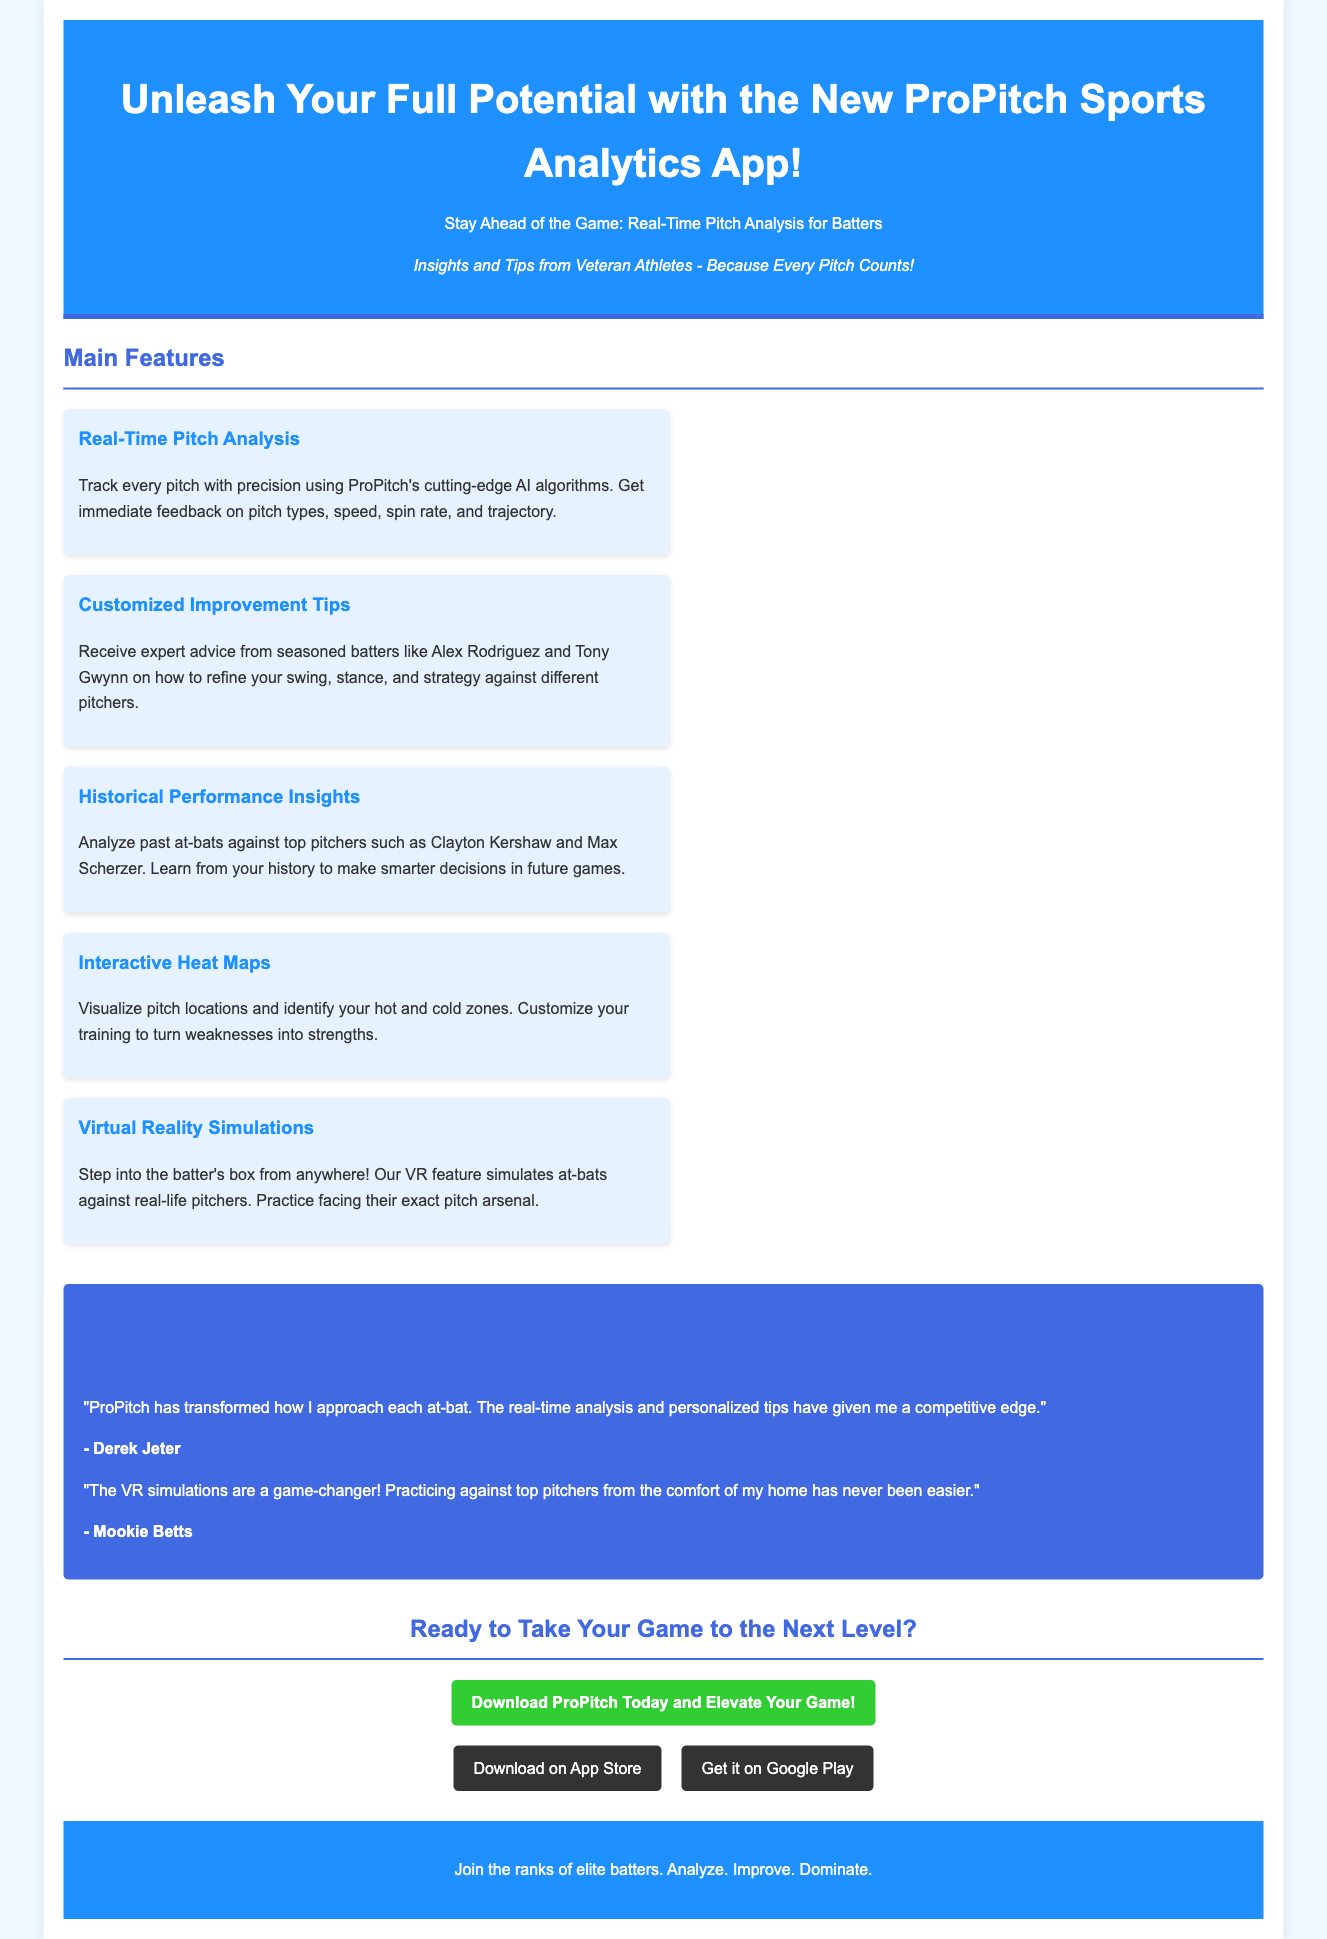What is the name of the app? The name of the app is mentioned in the header of the document as ProPitch Sports Analytics App.
Answer: ProPitch Sports Analytics App Who are some veteran athletes providing tips? The document lists Alex Rodriguez and Tony Gwynn as veteran athletes profiting expert advice.
Answer: Alex Rodriguez and Tony Gwynn What feature helps visualize pitch locations? The feature that aids in visualizing pitch locations is described as Interactive Heat Maps.
Answer: Interactive Heat Maps How many testimonials are provided from professional athletes? The document includes two testimonials from professional athletes, Derek Jeter and Mookie Betts.
Answer: Two What can batters practice against in the app’s VR feature? The VR feature allows batters to practice against real-life pitchers’ exact pitch arsenals.
Answer: Real-life pitchers’ exact pitch arsenals 